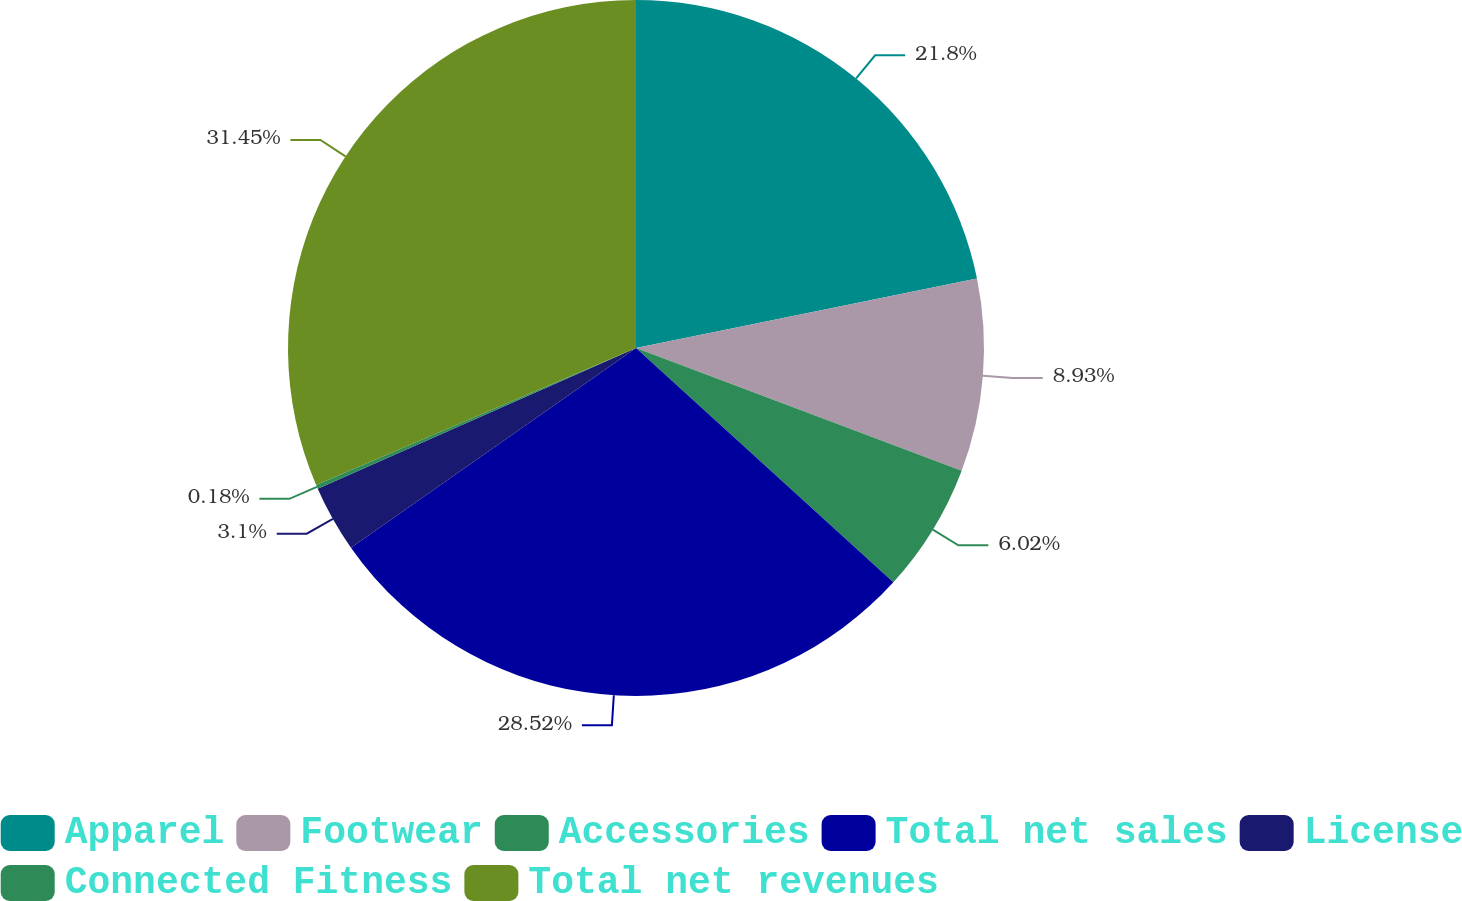<chart> <loc_0><loc_0><loc_500><loc_500><pie_chart><fcel>Apparel<fcel>Footwear<fcel>Accessories<fcel>Total net sales<fcel>License<fcel>Connected Fitness<fcel>Total net revenues<nl><fcel>21.8%<fcel>8.93%<fcel>6.02%<fcel>28.52%<fcel>3.1%<fcel>0.18%<fcel>31.44%<nl></chart> 